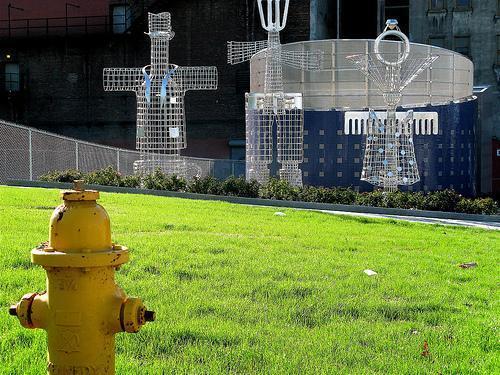How many fire hydrants are purple?
Give a very brief answer. 0. 